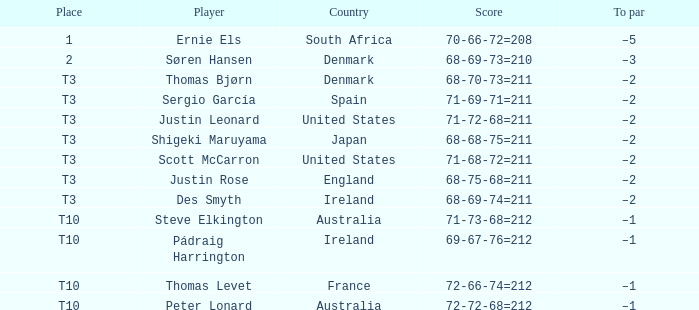What was australia's count when peter lonard took part? 72-72-68=212. 